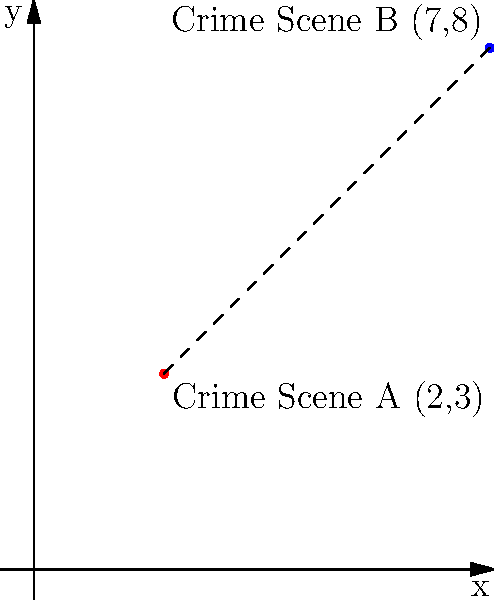Two crime scenes have been identified at locations A(2,3) and B(7,8) on a coordinate grid representing city blocks. Calculate the straight-line distance between these two locations to determine the minimum travel distance for evidence transport. To calculate the straight-line distance between two points, we can use the distance formula derived from the Pythagorean theorem:

$$d = \sqrt{(x_2 - x_1)^2 + (y_2 - y_1)^2}$$

Where $(x_1, y_1)$ represents the coordinates of point A and $(x_2, y_2)$ represents the coordinates of point B.

Step 1: Identify the coordinates
A(2,3) and B(7,8)
$(x_1, y_1) = (2, 3)$
$(x_2, y_2) = (7, 8)$

Step 2: Plug the values into the distance formula
$$d = \sqrt{(7 - 2)^2 + (8 - 3)^2}$$

Step 3: Simplify the expressions inside the parentheses
$$d = \sqrt{5^2 + 5^2}$$

Step 4: Calculate the squares
$$d = \sqrt{25 + 25}$$

Step 5: Add the values under the square root
$$d = \sqrt{50}$$

Step 6: Simplify the square root
$$d = 5\sqrt{2}$$

Therefore, the straight-line distance between the two crime scenes is $5\sqrt{2}$ units.
Answer: $5\sqrt{2}$ units 